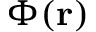<formula> <loc_0><loc_0><loc_500><loc_500>\Phi ( r )</formula> 